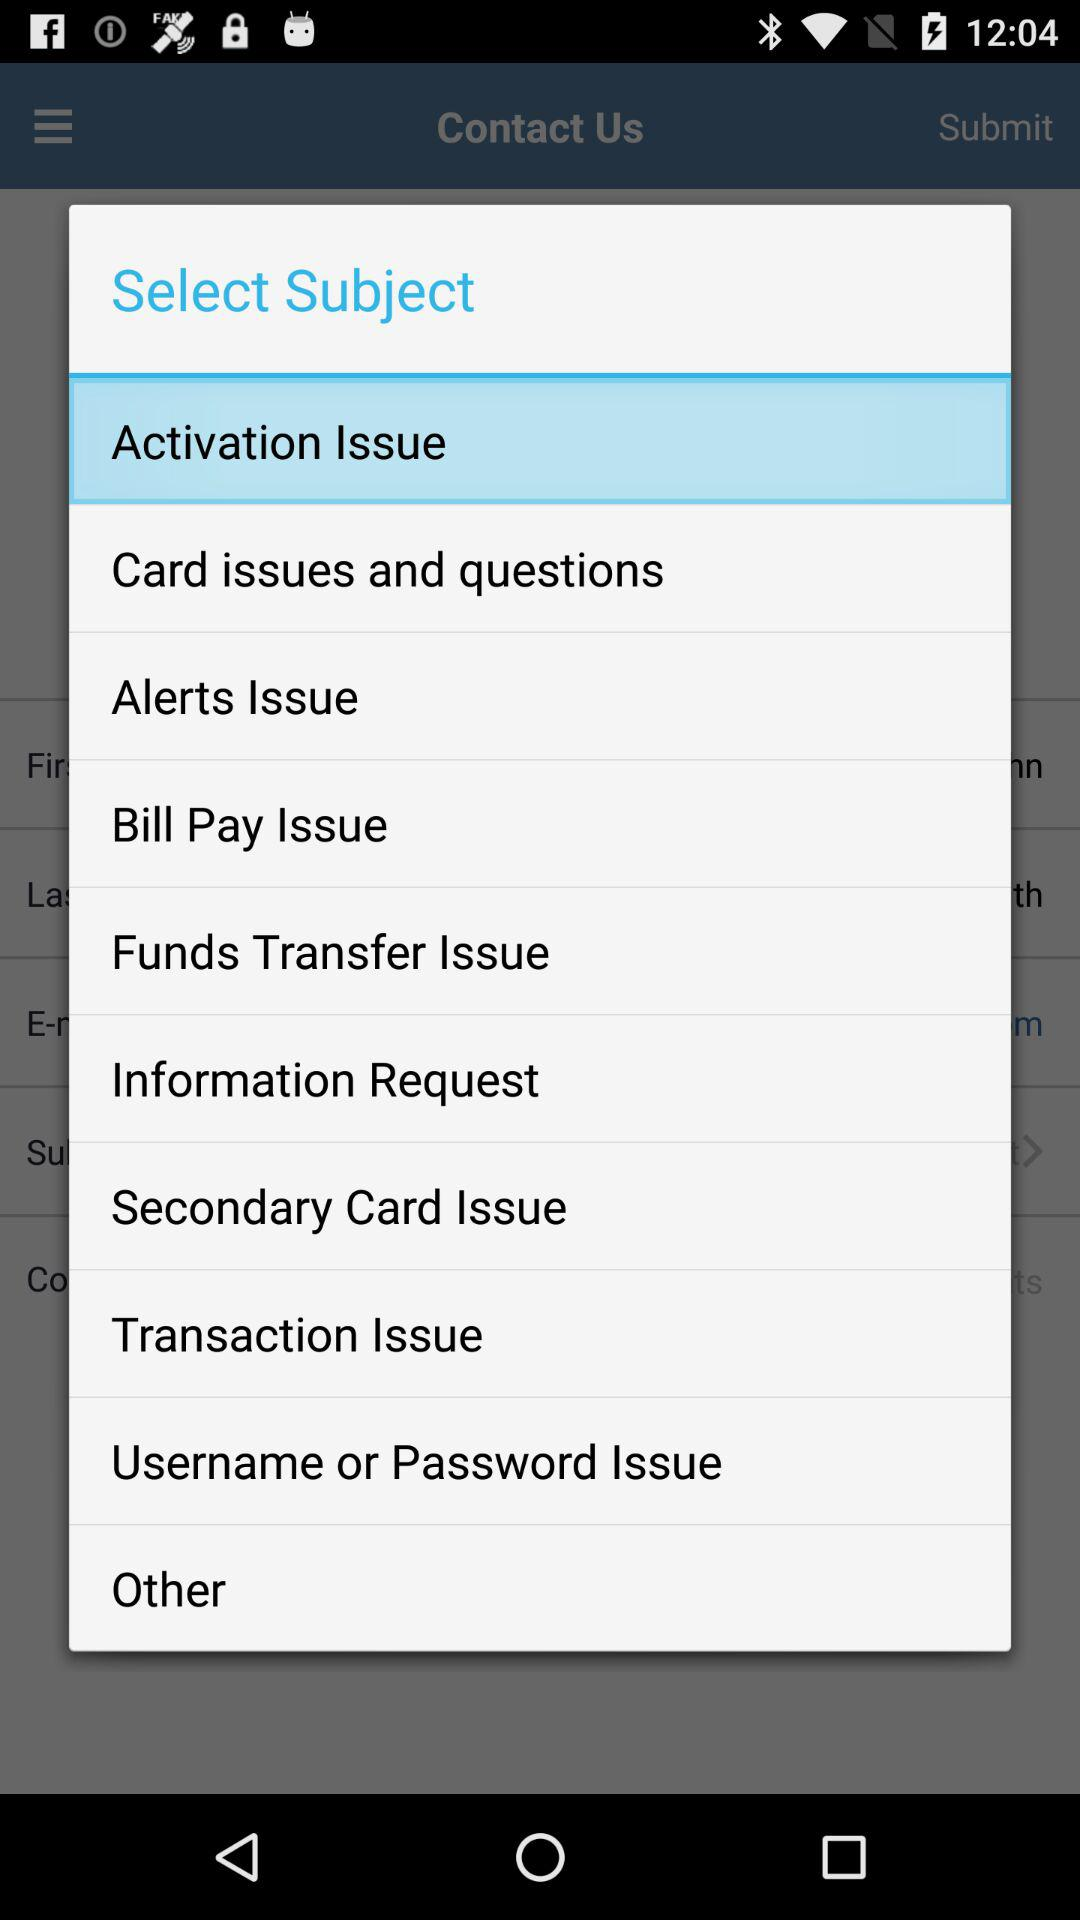When was the last transaction issued?
When the provided information is insufficient, respond with <no answer>. <no answer> 